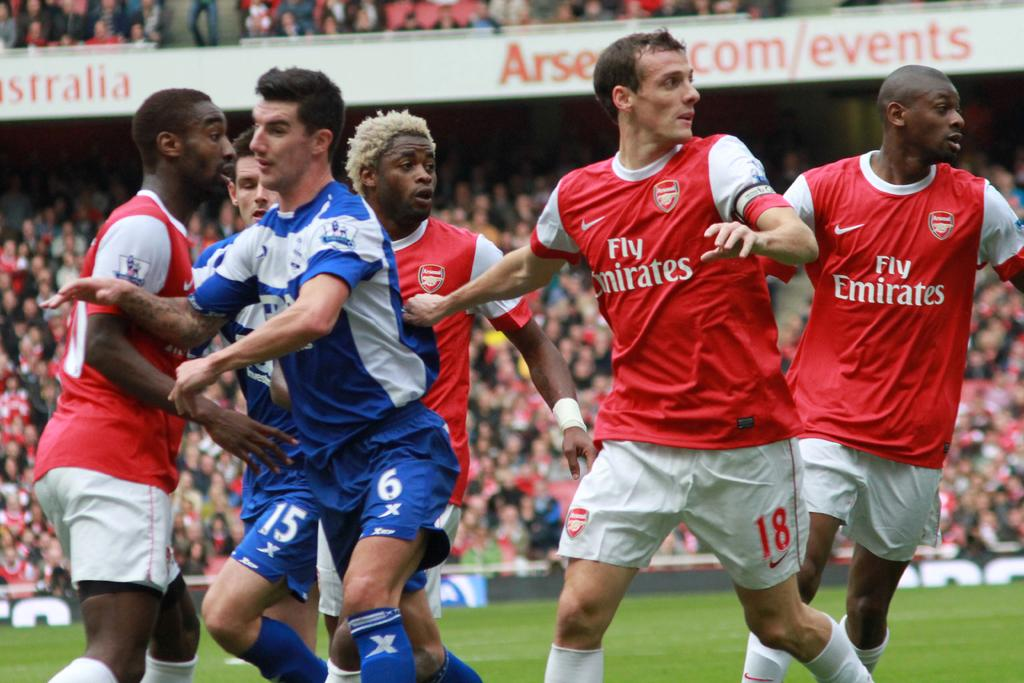<image>
Describe the image concisely. fly emirates is one of the teams playing the soccer game 